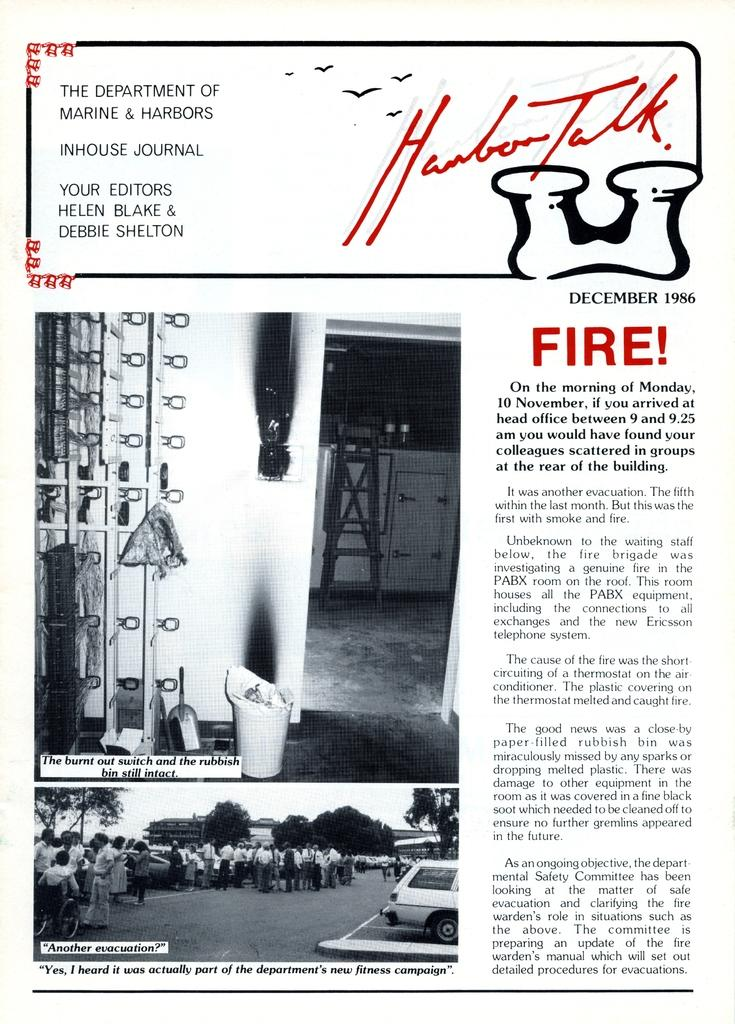What is present on the paper in the image? There are images and text on the paper. Can you describe the images on the paper? Unfortunately, the specific images on the paper cannot be described without more information. What type of information might be conveyed by the text on the paper? The text on the paper could convey various types of information, such as instructions, a story, or a message. How many prisoners are visible in the image? There are no prisoners present in the image; it features a paper with images and text. What type of feast is being prepared in the image? There is no feast being prepared in the image; it features a paper with images and text. 